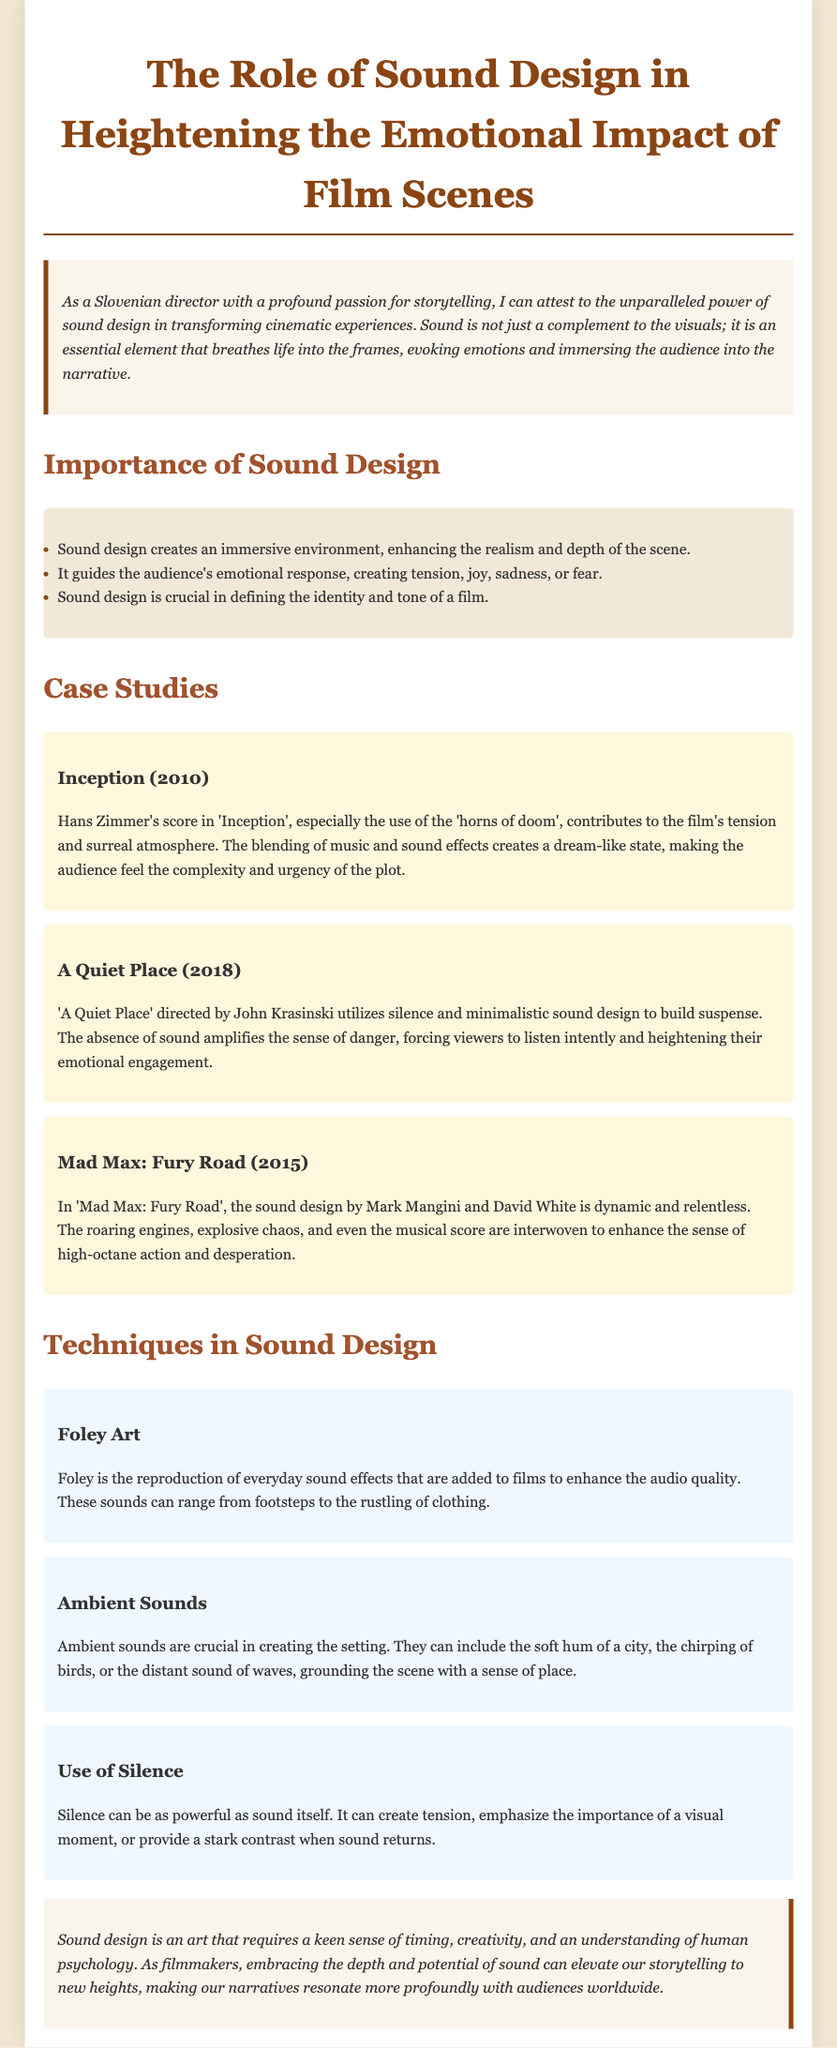what is the title of the document? The title of the document is prominently featured at the top of the page, summarizing its focus on sound design in film.
Answer: The Role of Sound Design in Heightening the Emotional Impact of Film Scenes who composed the score for Inception? The document mentions the composer of the score specifically in relation to the film 'Inception'.
Answer: Hans Zimmer in which year was A Quiet Place released? The release year of 'A Quiet Place' is provided in the case study section discussing its sound design.
Answer: 2018 what is one technique mentioned in the document related to sound design? The document includes several techniques in sound design, with a specific section dedicated to explaining these techniques.
Answer: Foley Art how does silence impact a film scene? The document explains the significance of silence in sound design and its emotional effects on the audience.
Answer: Creates tension which movie features the use of ‘horns of doom’? The document highlights a specific sound element used in the score of a certain film, identifying it clearly.
Answer: Inception who directed A Quiet Place? The document states the director's name in the case study of 'A Quiet Place', adding context to the discussion.
Answer: John Krasinski what emotional responses can sound design evoke? The document outlines the role of sound design in influencing audience reactions during film scenes.
Answer: Tension, joy, sadness, fear what is a key point about sound design’s importance? The document lists crucial aspects of sound design, reflecting on its value in film production.
Answer: Creates an immersive environment 